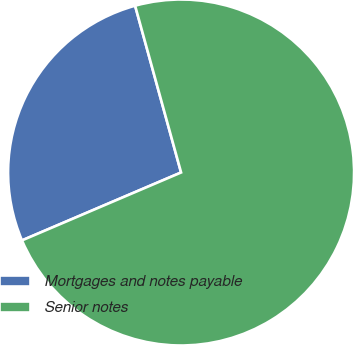<chart> <loc_0><loc_0><loc_500><loc_500><pie_chart><fcel>Mortgages and notes payable<fcel>Senior notes<nl><fcel>27.14%<fcel>72.86%<nl></chart> 